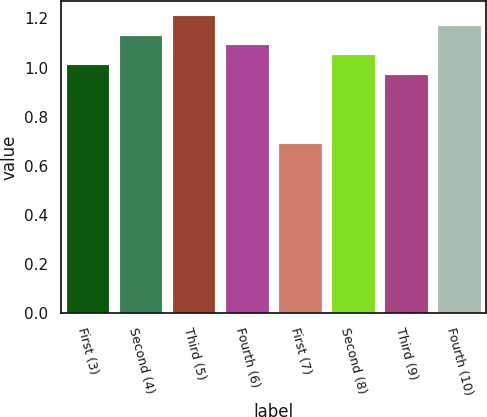Convert chart. <chart><loc_0><loc_0><loc_500><loc_500><bar_chart><fcel>First (3)<fcel>Second (4)<fcel>Third (5)<fcel>Fourth (6)<fcel>First (7)<fcel>Second (8)<fcel>Third (9)<fcel>Fourth (10)<nl><fcel>1.01<fcel>1.13<fcel>1.21<fcel>1.09<fcel>0.69<fcel>1.05<fcel>0.97<fcel>1.17<nl></chart> 